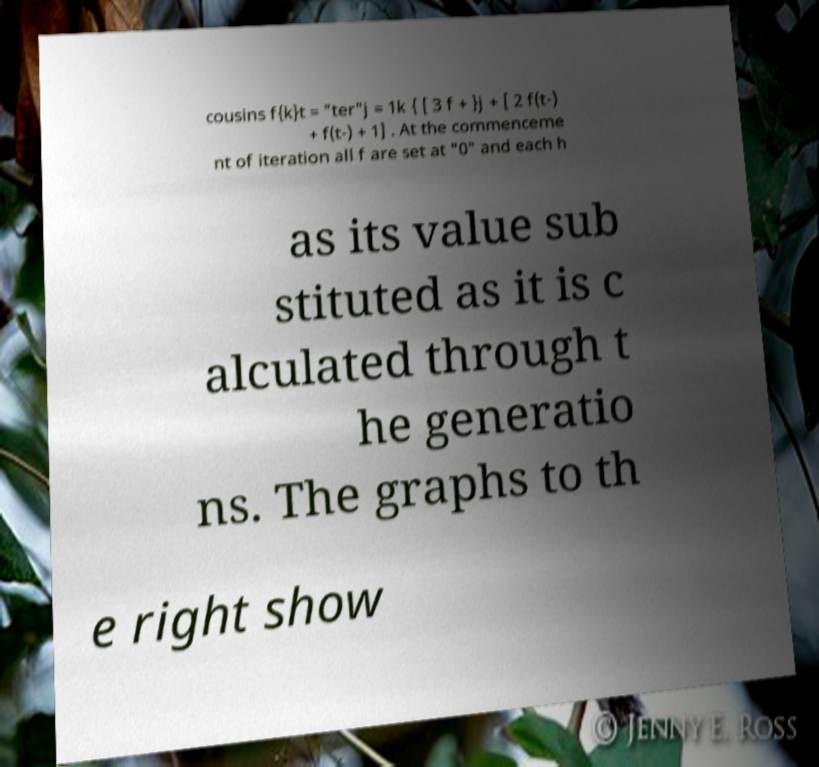Please read and relay the text visible in this image. What does it say? cousins f{k}t = "ter"j = 1k { [ 3 f + }j + [ 2 f(t-) + f(t-) + 1] . At the commenceme nt of iteration all f are set at "0" and each h as its value sub stituted as it is c alculated through t he generatio ns. The graphs to th e right show 